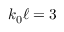Convert formula to latex. <formula><loc_0><loc_0><loc_500><loc_500>k _ { 0 } \ell = 3</formula> 